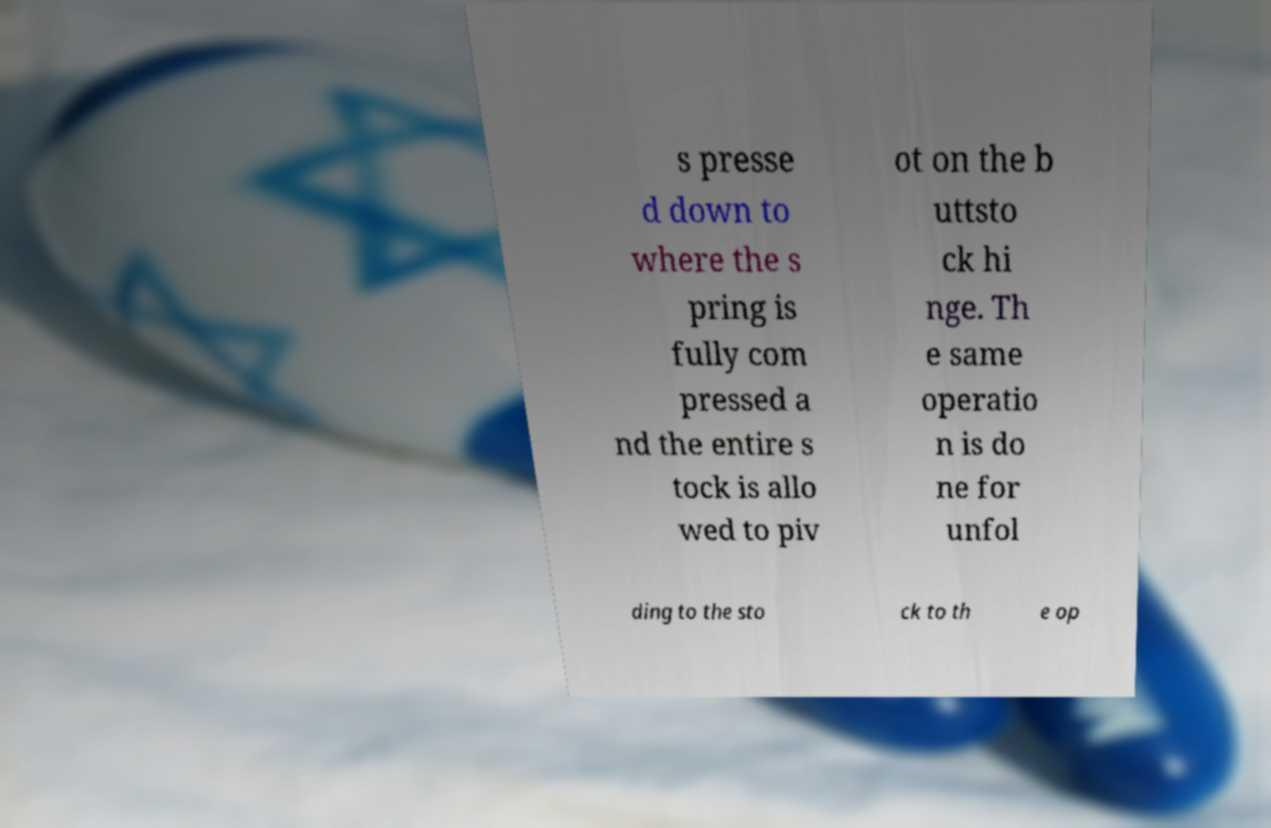Could you assist in decoding the text presented in this image and type it out clearly? s presse d down to where the s pring is fully com pressed a nd the entire s tock is allo wed to piv ot on the b uttsto ck hi nge. Th e same operatio n is do ne for unfol ding to the sto ck to th e op 